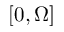<formula> <loc_0><loc_0><loc_500><loc_500>[ 0 , \Omega ]</formula> 